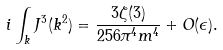<formula> <loc_0><loc_0><loc_500><loc_500>i \int _ { k } J ^ { 3 } ( k ^ { 2 } ) = \frac { 3 \zeta ( 3 ) } { 2 5 6 \pi ^ { 4 } m ^ { 4 } } + O ( \epsilon ) .</formula> 